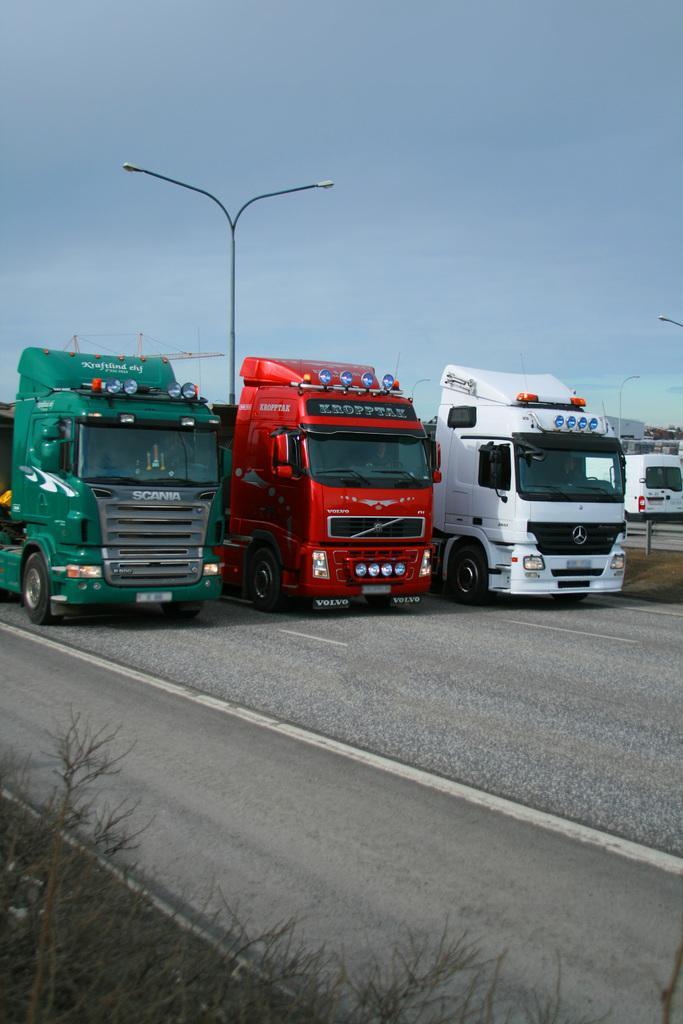Could you give a brief overview of what you see in this image? In this image we can see three trucks which are in different colors like red, white and green are, moving on road and in the background of the image there are some lights, vehicles and clear sky. 